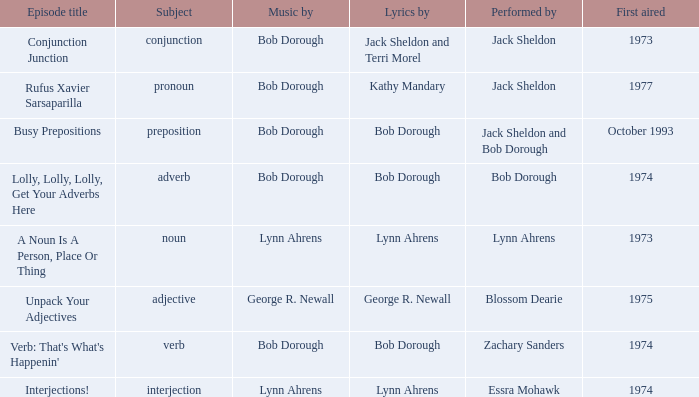When interjection is the subject how many performers are there? 1.0. 